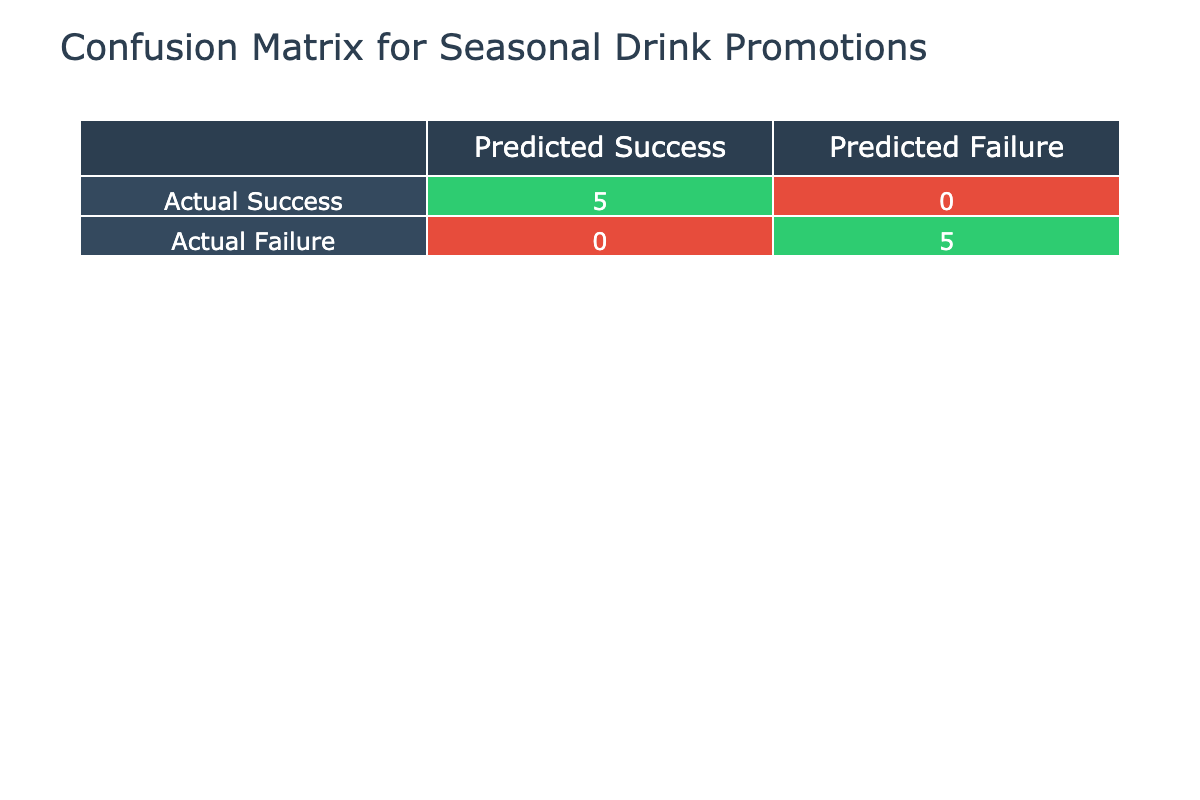What is the actual number of promotions that were considered successful? From the table, the promotions marked as "Successful" are Tropical Punch Fiesta, Autumn Cider Special, Spring Fling Cocktails, Classic Martini Month, and Spicy Margarita Week. Counting these gives us a total of 5 successful promotions.
Answer: 5 How many promotions had an actual sales number less than the expected demand? By checking each promotion's actual sales against the expected demand, we find that Winter Warmers Promotion, Craft Beer Showcase, and Fruit Sangria Event all had actual sales lower than expected. This gives us a total of 3 promotions with lower actual sales.
Answer: 3 What is the total number of promotions executed? The table lists 10 different promotions. To find the total, we simply count each promotion listed, leading us to determine that there were 10 promotions in total.
Answer: 10 Is it true that Summer Spritz Campaign had successful sales performance? The Summer Spritz Campaign is marked as "Not Successful" in the Promotion Success column, therefore it did not meet the expectations set for it.
Answer: No How many promotions showed a successful performance while also achieving actual sales above expected demand? We look for promotions that are marked "Successful" and also had actual sales greater than or equal to expected demand. These promotions are Tropical Punch Fiesta, Autumn Cider Special, Spring Fling Cocktails, and Spicy Margarita Week, which gives us a total of 4 promotions.
Answer: 4 What is the difference in actual sales between the most successful promotion and the least successful promotion? The most successful promotion is Tropical Punch Fiesta with actual sales of 100, while the least successful promotion is Craft Beer Showcase with actual sales of 40. The difference in sales is calculated as 100 - 40 = 60.
Answer: 60 How many promotions were not successful but had actual sales exceeding 70? The promotions that are marked as "Not Successful" are Winter Warmers Promotion, Summer Spritz Campaign, Craft Beer Showcase, and Fruit Sangria Event. Among these, only Summer Spritz Campaign (110) exceeds 70. Therefore, the total count is 1.
Answer: 1 Did more promotions succeed than fail? Looking at the totals, there are 5 successful promotions and 5 not successful promotions. Since both totals are equal, the answer is no.
Answer: No 